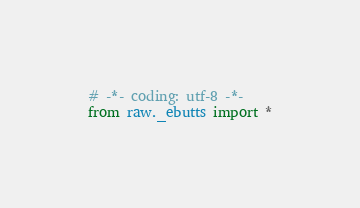Convert code to text. <code><loc_0><loc_0><loc_500><loc_500><_Python_># -*- coding: utf-8 -*-
from raw._ebutts import *
</code> 